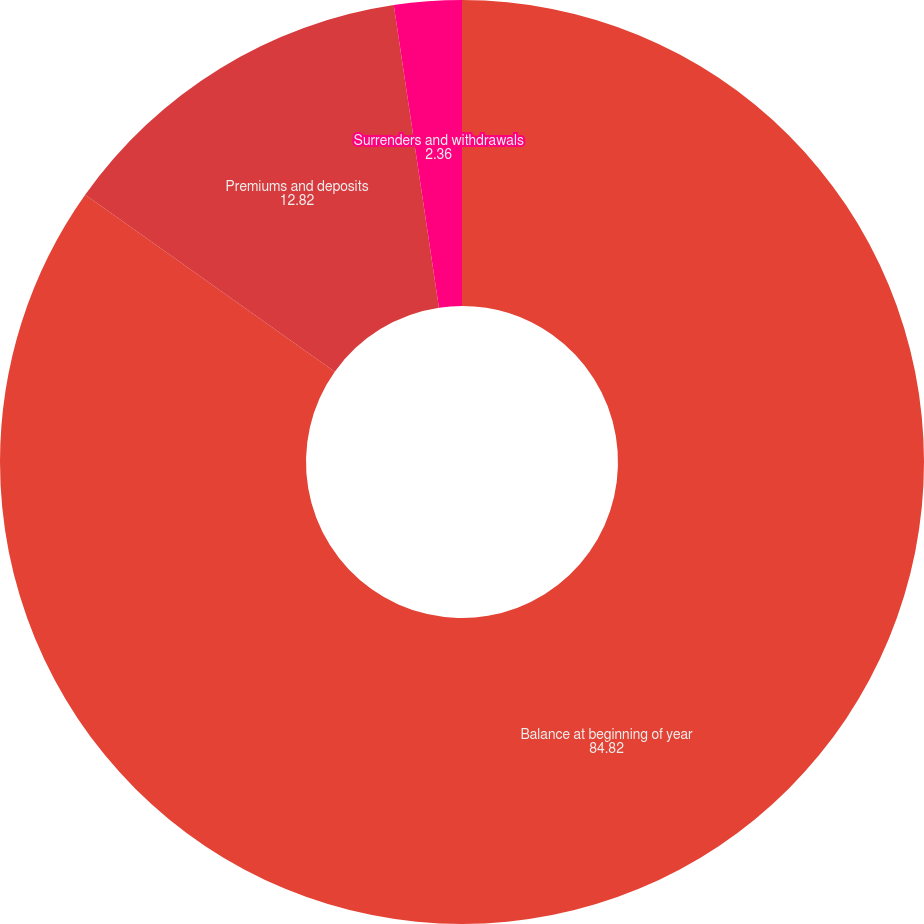Convert chart to OTSL. <chart><loc_0><loc_0><loc_500><loc_500><pie_chart><fcel>Balance at beginning of year<fcel>Premiums and deposits<fcel>Surrenders and withdrawals<nl><fcel>84.82%<fcel>12.82%<fcel>2.36%<nl></chart> 